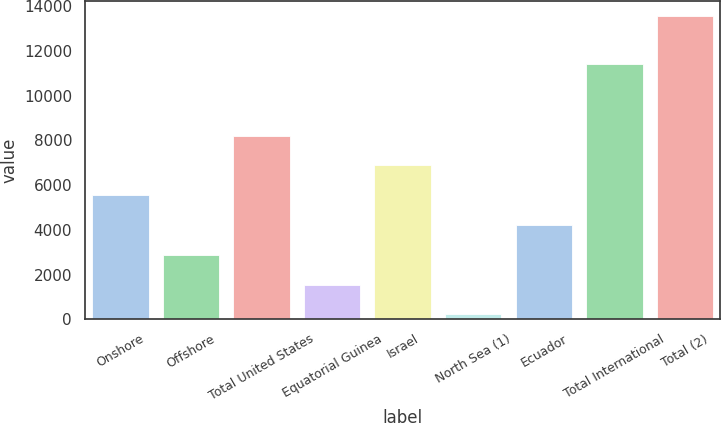Convert chart to OTSL. <chart><loc_0><loc_0><loc_500><loc_500><bar_chart><fcel>Onshore<fcel>Offshore<fcel>Total United States<fcel>Equatorial Guinea<fcel>Israel<fcel>North Sea (1)<fcel>Ecuador<fcel>Total International<fcel>Total (2)<nl><fcel>5552.2<fcel>2890.6<fcel>8213.8<fcel>1559.8<fcel>6883<fcel>229<fcel>4221.4<fcel>11410<fcel>13537<nl></chart> 